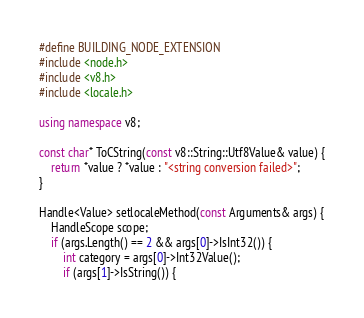Convert code to text. <code><loc_0><loc_0><loc_500><loc_500><_C++_>#define BUILDING_NODE_EXTENSION
#include <node.h>
#include <v8.h>
#include <locale.h>

using namespace v8;

const char* ToCString(const v8::String::Utf8Value& value) {
    return *value ? *value : "<string conversion failed>";
}

Handle<Value> setlocaleMethod(const Arguments& args) {
    HandleScope scope;
    if (args.Length() == 2 && args[0]->IsInt32()) {
        int category = args[0]->Int32Value();
        if (args[1]->IsString()) {</code> 